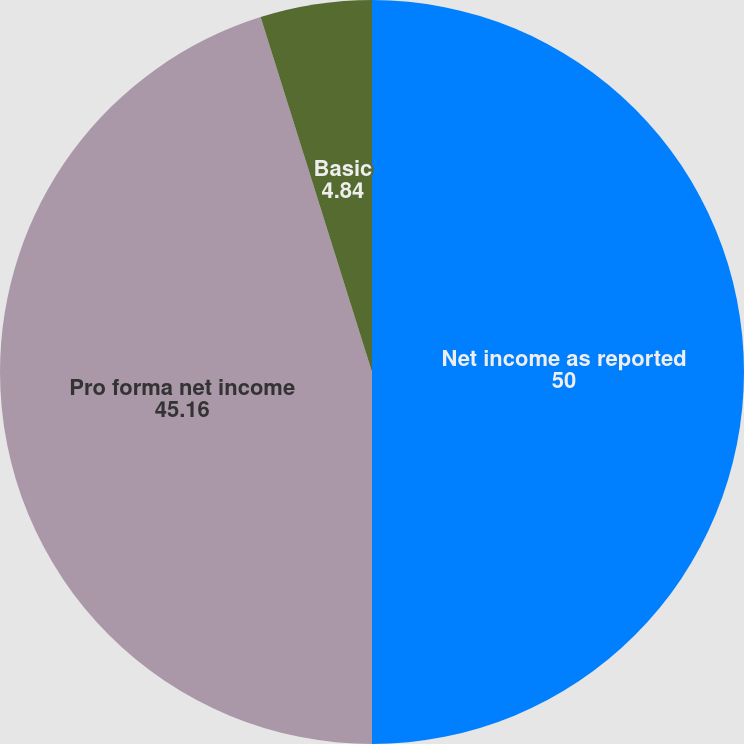Convert chart. <chart><loc_0><loc_0><loc_500><loc_500><pie_chart><fcel>Net income as reported<fcel>Pro forma net income<fcel>Basic<fcel>Diluted<nl><fcel>50.0%<fcel>45.16%<fcel>4.84%<fcel>0.0%<nl></chart> 